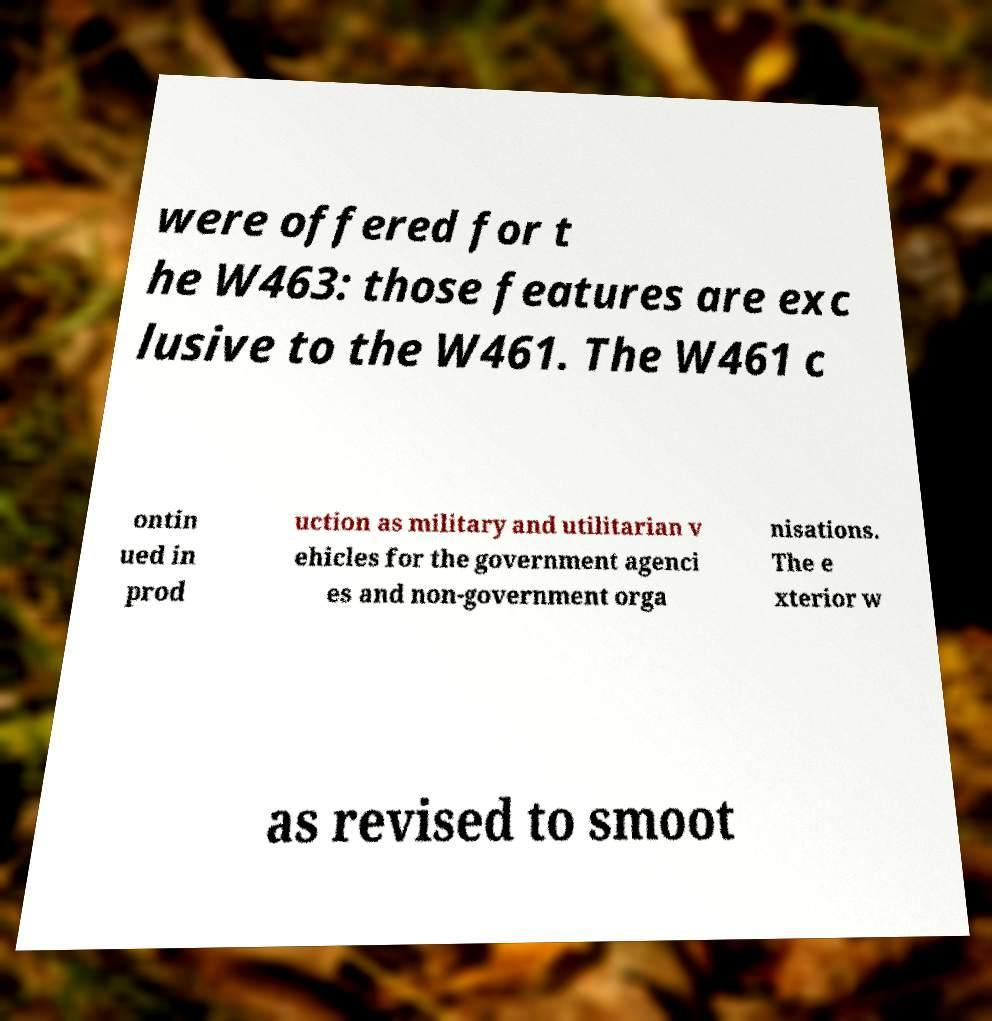What messages or text are displayed in this image? I need them in a readable, typed format. were offered for t he W463: those features are exc lusive to the W461. The W461 c ontin ued in prod uction as military and utilitarian v ehicles for the government agenci es and non-government orga nisations. The e xterior w as revised to smoot 